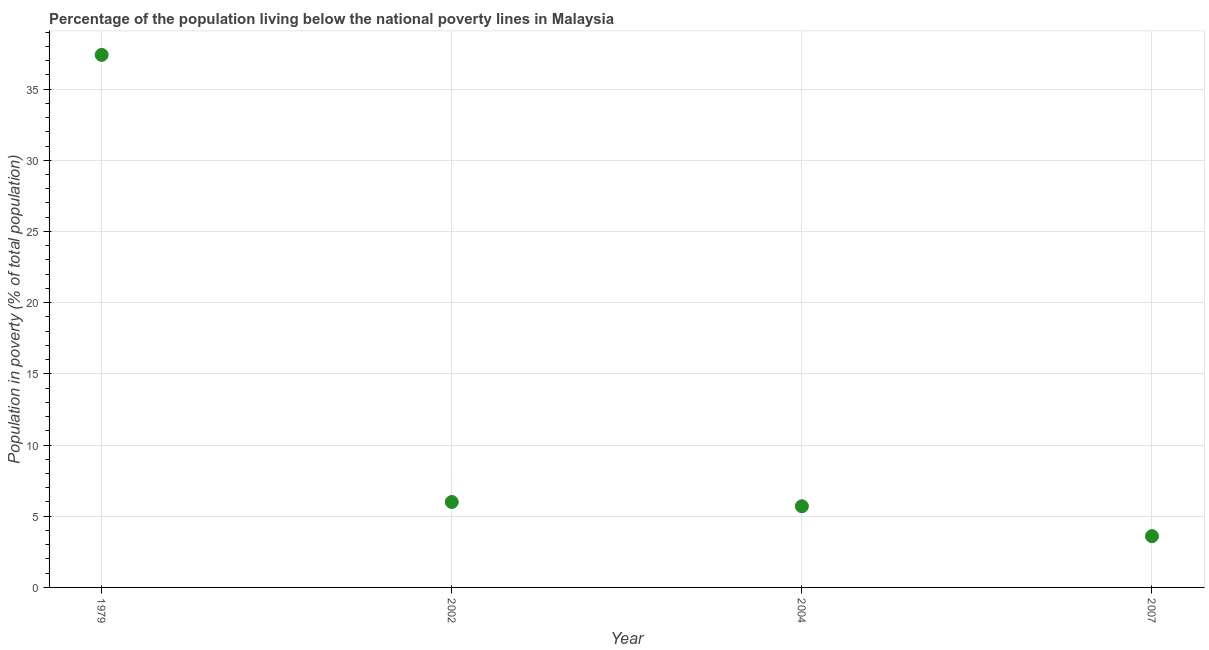What is the percentage of population living below poverty line in 2002?
Provide a short and direct response. 6. Across all years, what is the maximum percentage of population living below poverty line?
Provide a succinct answer. 37.4. In which year was the percentage of population living below poverty line maximum?
Offer a terse response. 1979. In which year was the percentage of population living below poverty line minimum?
Make the answer very short. 2007. What is the sum of the percentage of population living below poverty line?
Your answer should be very brief. 52.7. What is the difference between the percentage of population living below poverty line in 2002 and 2004?
Your answer should be compact. 0.3. What is the average percentage of population living below poverty line per year?
Your answer should be very brief. 13.18. What is the median percentage of population living below poverty line?
Give a very brief answer. 5.85. In how many years, is the percentage of population living below poverty line greater than 3 %?
Your response must be concise. 4. What is the ratio of the percentage of population living below poverty line in 1979 to that in 2002?
Provide a short and direct response. 6.23. Is the percentage of population living below poverty line in 2004 less than that in 2007?
Offer a very short reply. No. Is the difference between the percentage of population living below poverty line in 1979 and 2004 greater than the difference between any two years?
Your answer should be very brief. No. What is the difference between the highest and the second highest percentage of population living below poverty line?
Your answer should be very brief. 31.4. What is the difference between the highest and the lowest percentage of population living below poverty line?
Provide a succinct answer. 33.8. In how many years, is the percentage of population living below poverty line greater than the average percentage of population living below poverty line taken over all years?
Ensure brevity in your answer.  1. Does the percentage of population living below poverty line monotonically increase over the years?
Your response must be concise. No. How many dotlines are there?
Your answer should be compact. 1. Are the values on the major ticks of Y-axis written in scientific E-notation?
Your answer should be very brief. No. What is the title of the graph?
Your answer should be compact. Percentage of the population living below the national poverty lines in Malaysia. What is the label or title of the Y-axis?
Make the answer very short. Population in poverty (% of total population). What is the Population in poverty (% of total population) in 1979?
Provide a short and direct response. 37.4. What is the Population in poverty (% of total population) in 2004?
Give a very brief answer. 5.7. What is the difference between the Population in poverty (% of total population) in 1979 and 2002?
Your answer should be compact. 31.4. What is the difference between the Population in poverty (% of total population) in 1979 and 2004?
Keep it short and to the point. 31.7. What is the difference between the Population in poverty (% of total population) in 1979 and 2007?
Give a very brief answer. 33.8. What is the difference between the Population in poverty (% of total population) in 2002 and 2004?
Your answer should be very brief. 0.3. What is the difference between the Population in poverty (% of total population) in 2002 and 2007?
Your answer should be very brief. 2.4. What is the difference between the Population in poverty (% of total population) in 2004 and 2007?
Keep it short and to the point. 2.1. What is the ratio of the Population in poverty (% of total population) in 1979 to that in 2002?
Your answer should be compact. 6.23. What is the ratio of the Population in poverty (% of total population) in 1979 to that in 2004?
Offer a very short reply. 6.56. What is the ratio of the Population in poverty (% of total population) in 1979 to that in 2007?
Offer a terse response. 10.39. What is the ratio of the Population in poverty (% of total population) in 2002 to that in 2004?
Keep it short and to the point. 1.05. What is the ratio of the Population in poverty (% of total population) in 2002 to that in 2007?
Make the answer very short. 1.67. What is the ratio of the Population in poverty (% of total population) in 2004 to that in 2007?
Your response must be concise. 1.58. 